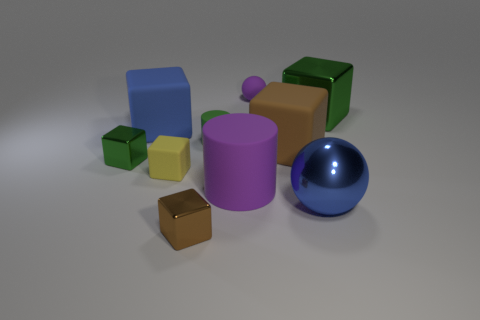Is there any object that appears to be in the foreground due to its size or placement? Certainly, the blue sphere appears to be in the foreground, its size and placement at the front give it a prominent presence compared to the other objects. 